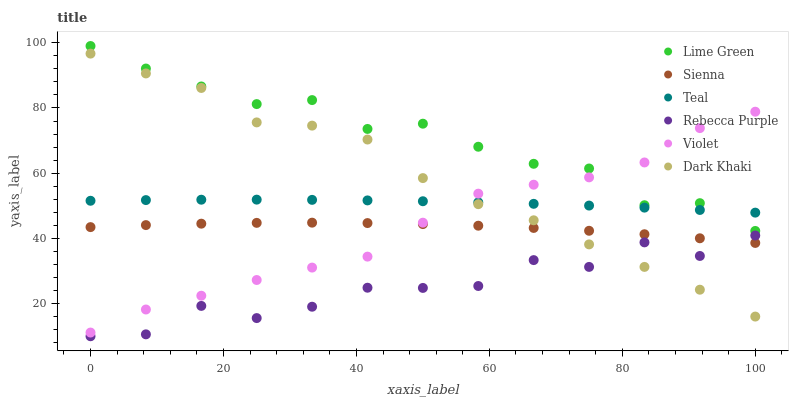Does Rebecca Purple have the minimum area under the curve?
Answer yes or no. Yes. Does Lime Green have the maximum area under the curve?
Answer yes or no. Yes. Does Sienna have the minimum area under the curve?
Answer yes or no. No. Does Sienna have the maximum area under the curve?
Answer yes or no. No. Is Teal the smoothest?
Answer yes or no. Yes. Is Rebecca Purple the roughest?
Answer yes or no. Yes. Is Sienna the smoothest?
Answer yes or no. No. Is Sienna the roughest?
Answer yes or no. No. Does Rebecca Purple have the lowest value?
Answer yes or no. Yes. Does Sienna have the lowest value?
Answer yes or no. No. Does Lime Green have the highest value?
Answer yes or no. Yes. Does Sienna have the highest value?
Answer yes or no. No. Is Dark Khaki less than Lime Green?
Answer yes or no. Yes. Is Teal greater than Sienna?
Answer yes or no. Yes. Does Lime Green intersect Violet?
Answer yes or no. Yes. Is Lime Green less than Violet?
Answer yes or no. No. Is Lime Green greater than Violet?
Answer yes or no. No. Does Dark Khaki intersect Lime Green?
Answer yes or no. No. 